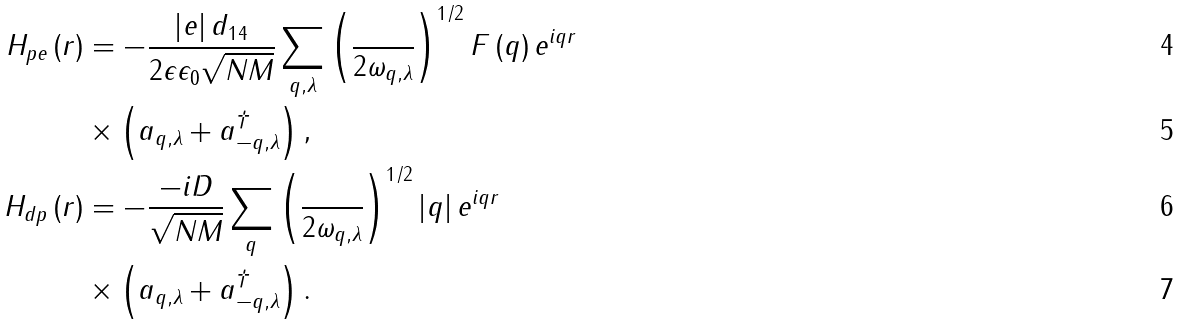Convert formula to latex. <formula><loc_0><loc_0><loc_500><loc_500>H _ { p e } \left ( r \right ) & = - \frac { \left | e \right | d _ { 1 4 } } { 2 \epsilon \epsilon _ { 0 } \sqrt { N M } } \sum _ { q , \lambda } \left ( \frac { } { 2 \omega _ { q , \lambda } } \right ) ^ { 1 / 2 } F \left ( q \right ) e ^ { i q r } \\ & \times \left ( a _ { q , \lambda } + a _ { - q , \lambda } ^ { \dag } \right ) , \\ H _ { d p } \left ( r \right ) & = - \frac { - i D } { \sqrt { N M } } \sum _ { q } \left ( \frac { } { 2 \omega _ { q , \lambda } } \right ) ^ { 1 / 2 } \left | q \right | e ^ { i q r } \\ & \times \left ( a _ { q , \lambda } + a _ { - q , \lambda } ^ { \dag } \right ) .</formula> 